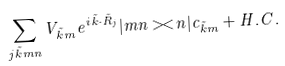Convert formula to latex. <formula><loc_0><loc_0><loc_500><loc_500>\sum _ { j \vec { k } m n } V _ { \vec { k } m } e ^ { i \vec { k } \cdot \vec { R } _ { j } } | m n > < n | c _ { \vec { k } m } + H . C .</formula> 